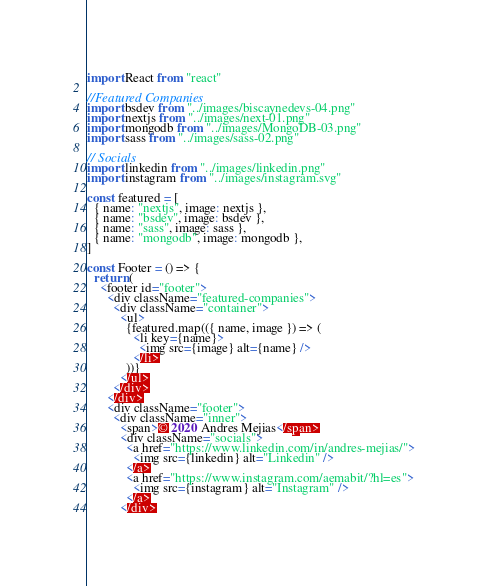Convert code to text. <code><loc_0><loc_0><loc_500><loc_500><_JavaScript_>import React from "react"

//Featured Companies
import bsdev from "../images/biscaynedevs-04.png"
import nextjs from "../images/next-01.png"
import mongodb from "../images/MongoDB-03.png"
import sass from "../images/sass-02.png"

// Socials
import linkedin from "../images/linkedin.png"
import instagram from "../images/instagram.svg"

const featured = [
  { name: "nextjs", image: nextjs },
  { name: "bsdev", image: bsdev },
  { name: "sass", image: sass },
  { name: "mongodb", image: mongodb },
]

const Footer = () => {
  return (
    <footer id="footer">
      <div className="featured-companies">
        <div className="container">
          <ul>
            {featured.map(({ name, image }) => (
              <li key={name}>
                <img src={image} alt={name} />
              </li>
            ))}
          </ul>
        </div>
      </div>
      <div className="footer">
        <div className="inner">
          <span>© 2020 Andres Mejias</span>
          <div className="socials">
            <a href="https://www.linkedin.com/in/andres-mejias/">
              <img src={linkedin} alt="Linkedin" />
            </a>
            <a href="https://www.instagram.com/aemabit/?hl=es">
              <img src={instagram} alt="Instagram" />
            </a>
          </div></code> 